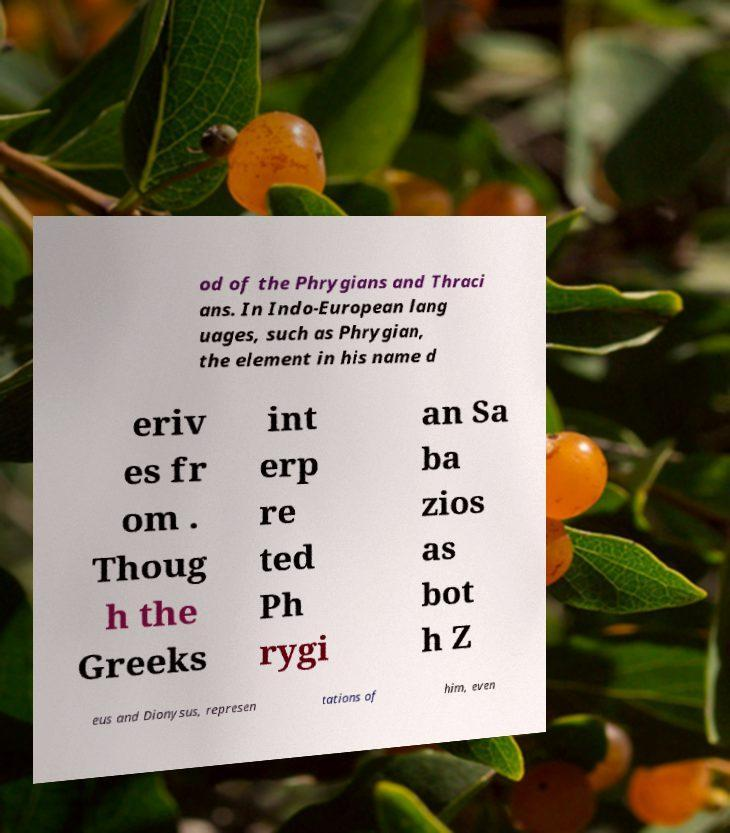Could you extract and type out the text from this image? od of the Phrygians and Thraci ans. In Indo-European lang uages, such as Phrygian, the element in his name d eriv es fr om . Thoug h the Greeks int erp re ted Ph rygi an Sa ba zios as bot h Z eus and Dionysus, represen tations of him, even 